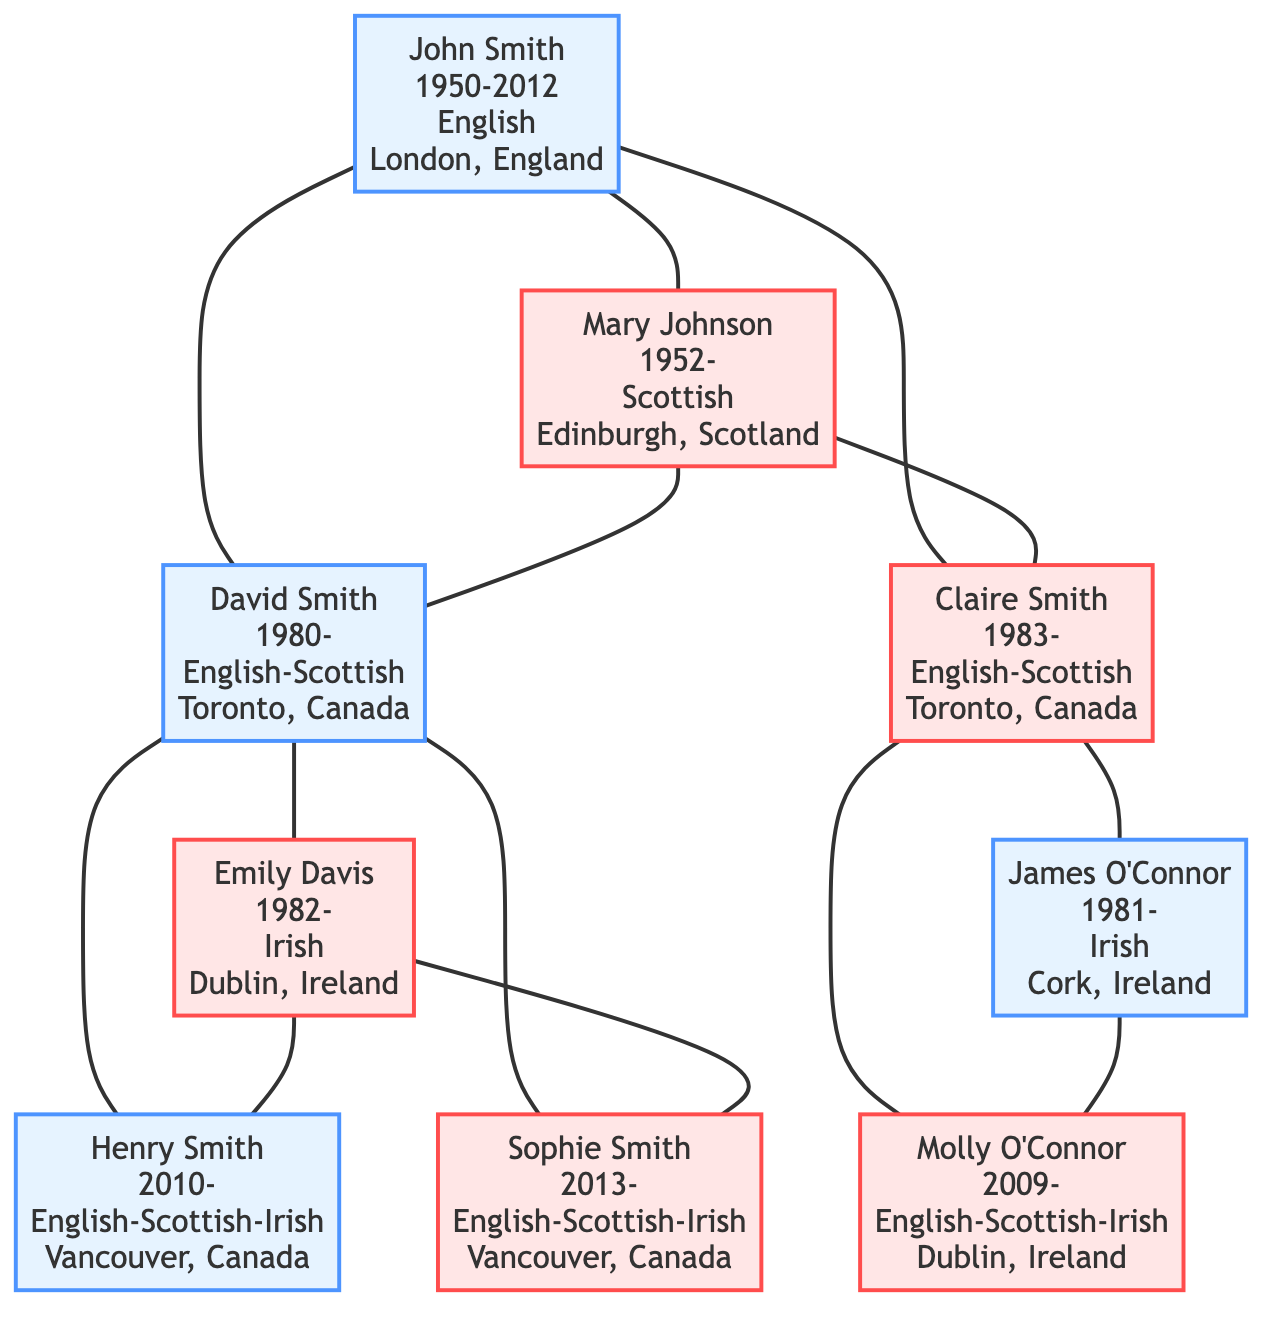What is the ethnicity of John Smith? In the diagram, John Smith is listed as having the ethnicity "English." This information is clearly labeled alongside his birth and death dates.
Answer: English How many children does John Smith have? By examining the connections from John Smith, there are connections to two children, David Smith and Claire Smith. Each is indicated through the branching structure of the family tree.
Answer: 2 What is the place of birth for Emily Davis? In the diagram for Emily Davis, it states her place of birth as "Dublin, Ireland." This is part of the information displayed next to her name in the visual representation.
Answer: Dublin, Ireland Which child of John Smith was born in 2010? Looking closely at the children of David Smith, Henry Smith is specifically noted to have been born in the year 2010, as indicated next to his name in the diagram.
Answer: Henry Smith What ethnicities combine in the grandchildren of John Smith? The grandchildren, Henry Smith, Sophie Smith, and Molly O'Connor, display ethnicities of "English-Scottish-Irish." This is determined by tracing back through their parents and is indicated in their respective sections within the tree.
Answer: English-Scottish-Irish Who is Claire Smith's spouse? The diagram directly connects Claire Smith to her spouse, James O'Connor, with a line, indicating their relationship clearly under her section in the tree.
Answer: James O'Connor What is the common birthplace of Henry and Sophie Smith? Both Henry Smith and Sophie Smith are noted to have the same birthplace, "Vancouver, Canada," which is identifiable next to each of their names in the diagram.
Answer: Vancouver, Canada Which spouse is of Scottish descent? Mary Johnson is the spouse identified with Scottish descent, as indicated next to her name in the diagram along with her birth date and place.
Answer: Mary Johnson How many generations are represented in the family tree? The family tree exhibits three generations: John Smith and Mary Johnson in the first generation, their children David and Claire in the second, and the grandchildren in the third. This can be counted based on the hierarchical connections shown.
Answer: 3 